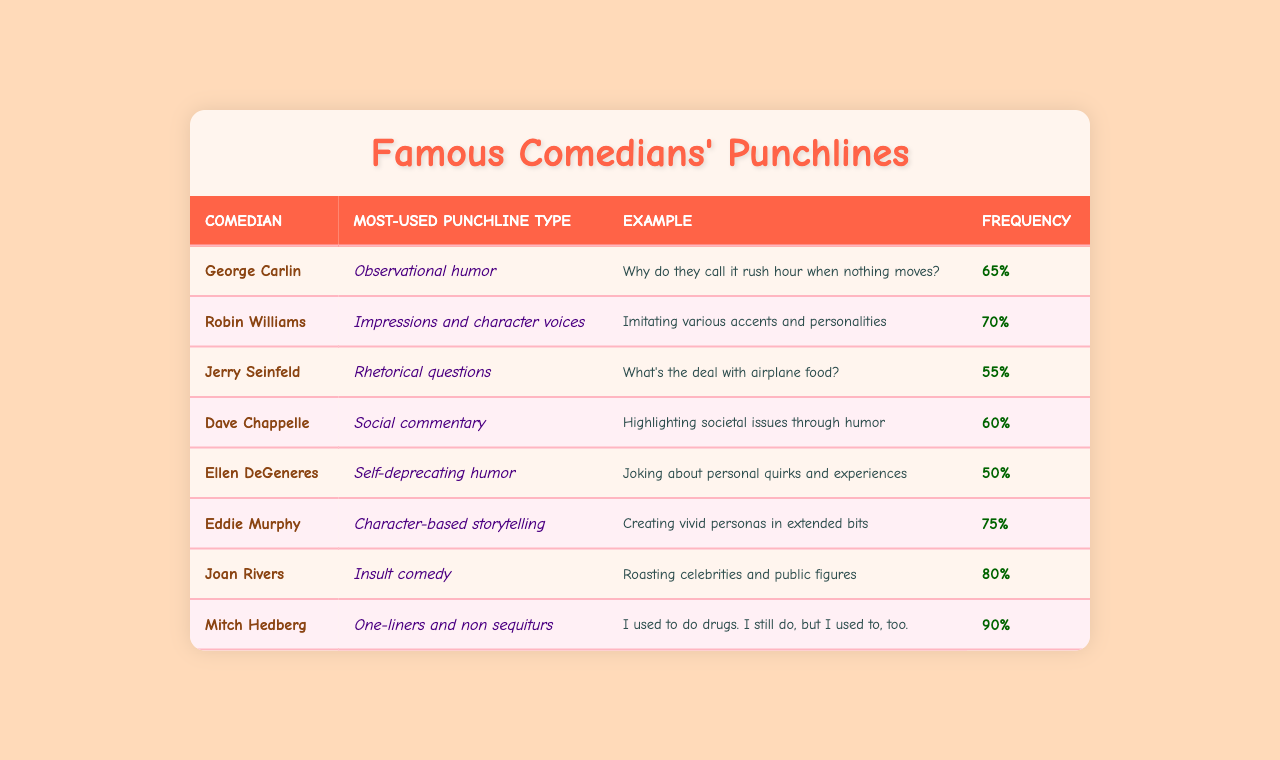What is the most-used punchline type by Joan Rivers? From the table, we can see that Joan Rivers' most-used punchline type is "Insult comedy."
Answer: Insult comedy Which comedian has the highest punchline frequency? By examining the frequencies in the table, Mitch Hedberg has the highest frequency at 90%.
Answer: 90% What punchline type is used by George Carlin? The table indicates that George Carlin uses "Observational humor" as his punchline type.
Answer: Observational humor How many comedians have a punchline frequency of 60% or higher? Looking through the table, we can count Dave Chappelle (60%), Eddie Murphy (75%), Joan Rivers (80%), and Mitch Hedberg (90%) totaling four comedians.
Answer: 4 Is "Self-deprecating humor" used by any comedian? The table shows that Ellen DeGeneres uses "Self-deprecating humor" as her most-used punchline type.
Answer: Yes What is the frequency of the punchline type used by Jerry Seinfeld? According to the table, Jerry Seinfeld's punchline type frequency is 55%.
Answer: 55% Who uses character-based storytelling the most? The table specifies that Eddie Murphy is known for "Character-based storytelling."
Answer: Eddie Murphy Which punchline type is least commonly used in the table? The punchline type with the lowest frequency in the table is "Self-deprecating humor" at 50%.
Answer: Self-deprecating humor What is the average punchline frequency of all comedians listed? To find the average, we sum the frequencies (65 + 70 + 55 + 60 + 50 + 75 + 80 + 90 = 600) and divide by 8, resulting in an average of 75.
Answer: 75 Do any comedians exclusively use rhetorical questions as their most-used punchline type? The table indicates that Jerry Seinfeld is the only comedian whose most-used type is "Rhetorical questions."
Answer: Yes 